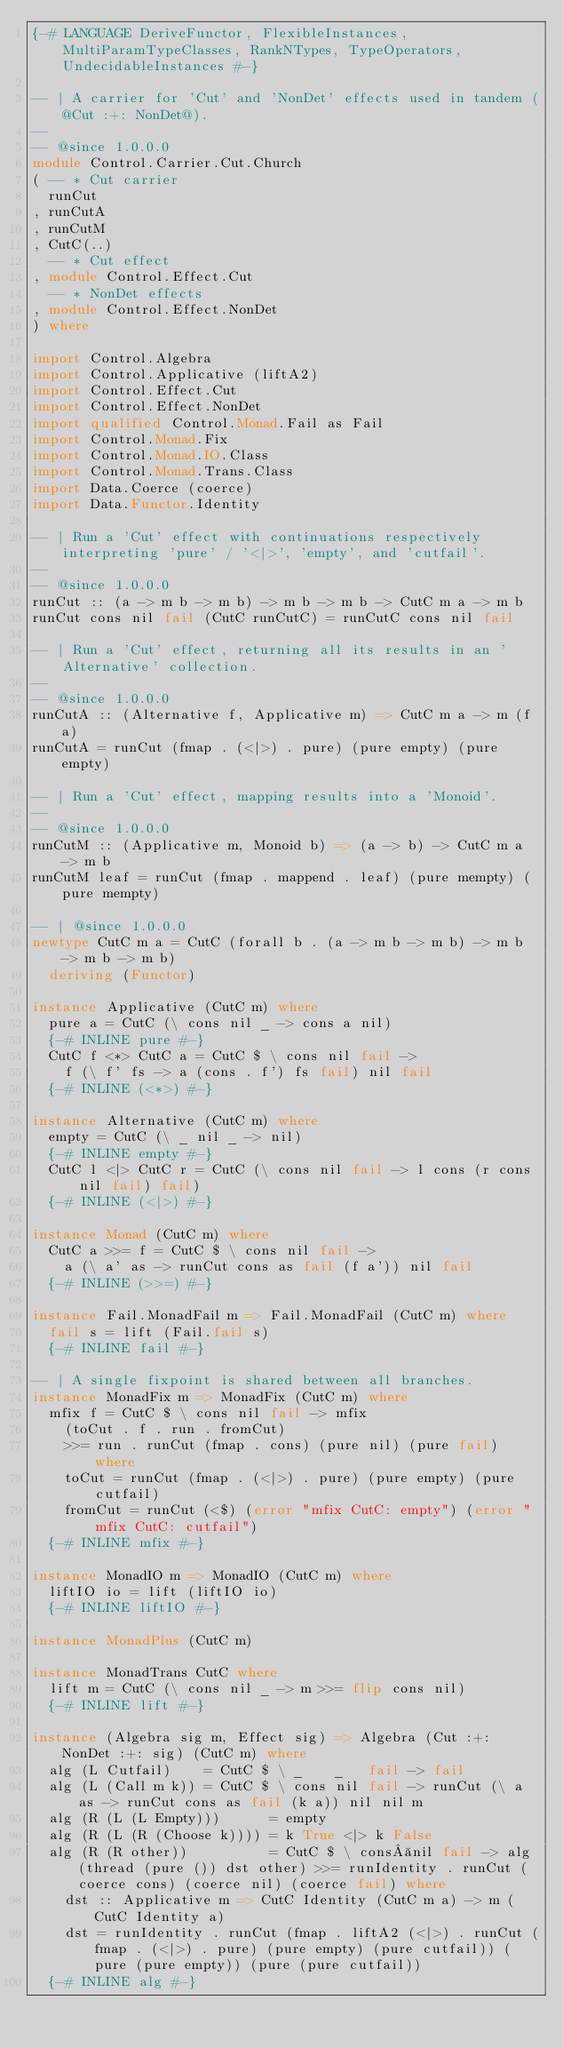Convert code to text. <code><loc_0><loc_0><loc_500><loc_500><_Haskell_>{-# LANGUAGE DeriveFunctor, FlexibleInstances, MultiParamTypeClasses, RankNTypes, TypeOperators, UndecidableInstances #-}

-- | A carrier for 'Cut' and 'NonDet' effects used in tandem (@Cut :+: NonDet@).
--
-- @since 1.0.0.0
module Control.Carrier.Cut.Church
( -- * Cut carrier
  runCut
, runCutA
, runCutM
, CutC(..)
  -- * Cut effect
, module Control.Effect.Cut
  -- * NonDet effects
, module Control.Effect.NonDet
) where

import Control.Algebra
import Control.Applicative (liftA2)
import Control.Effect.Cut
import Control.Effect.NonDet
import qualified Control.Monad.Fail as Fail
import Control.Monad.Fix
import Control.Monad.IO.Class
import Control.Monad.Trans.Class
import Data.Coerce (coerce)
import Data.Functor.Identity

-- | Run a 'Cut' effect with continuations respectively interpreting 'pure' / '<|>', 'empty', and 'cutfail'.
--
-- @since 1.0.0.0
runCut :: (a -> m b -> m b) -> m b -> m b -> CutC m a -> m b
runCut cons nil fail (CutC runCutC) = runCutC cons nil fail

-- | Run a 'Cut' effect, returning all its results in an 'Alternative' collection.
--
-- @since 1.0.0.0
runCutA :: (Alternative f, Applicative m) => CutC m a -> m (f a)
runCutA = runCut (fmap . (<|>) . pure) (pure empty) (pure empty)

-- | Run a 'Cut' effect, mapping results into a 'Monoid'.
--
-- @since 1.0.0.0
runCutM :: (Applicative m, Monoid b) => (a -> b) -> CutC m a -> m b
runCutM leaf = runCut (fmap . mappend . leaf) (pure mempty) (pure mempty)

-- | @since 1.0.0.0
newtype CutC m a = CutC (forall b . (a -> m b -> m b) -> m b -> m b -> m b)
  deriving (Functor)

instance Applicative (CutC m) where
  pure a = CutC (\ cons nil _ -> cons a nil)
  {-# INLINE pure #-}
  CutC f <*> CutC a = CutC $ \ cons nil fail ->
    f (\ f' fs -> a (cons . f') fs fail) nil fail
  {-# INLINE (<*>) #-}

instance Alternative (CutC m) where
  empty = CutC (\ _ nil _ -> nil)
  {-# INLINE empty #-}
  CutC l <|> CutC r = CutC (\ cons nil fail -> l cons (r cons nil fail) fail)
  {-# INLINE (<|>) #-}

instance Monad (CutC m) where
  CutC a >>= f = CutC $ \ cons nil fail ->
    a (\ a' as -> runCut cons as fail (f a')) nil fail
  {-# INLINE (>>=) #-}

instance Fail.MonadFail m => Fail.MonadFail (CutC m) where
  fail s = lift (Fail.fail s)
  {-# INLINE fail #-}

-- | A single fixpoint is shared between all branches.
instance MonadFix m => MonadFix (CutC m) where
  mfix f = CutC $ \ cons nil fail -> mfix
    (toCut . f . run . fromCut)
    >>= run . runCut (fmap . cons) (pure nil) (pure fail) where
    toCut = runCut (fmap . (<|>) . pure) (pure empty) (pure cutfail)
    fromCut = runCut (<$) (error "mfix CutC: empty") (error "mfix CutC: cutfail")
  {-# INLINE mfix #-}

instance MonadIO m => MonadIO (CutC m) where
  liftIO io = lift (liftIO io)
  {-# INLINE liftIO #-}

instance MonadPlus (CutC m)

instance MonadTrans CutC where
  lift m = CutC (\ cons nil _ -> m >>= flip cons nil)
  {-# INLINE lift #-}

instance (Algebra sig m, Effect sig) => Algebra (Cut :+: NonDet :+: sig) (CutC m) where
  alg (L Cutfail)    = CutC $ \ _    _   fail -> fail
  alg (L (Call m k)) = CutC $ \ cons nil fail -> runCut (\ a as -> runCut cons as fail (k a)) nil nil m
  alg (R (L (L Empty)))      = empty
  alg (R (L (R (Choose k)))) = k True <|> k False
  alg (R (R other))          = CutC $ \ cons nil fail -> alg (thread (pure ()) dst other) >>= runIdentity . runCut (coerce cons) (coerce nil) (coerce fail) where
    dst :: Applicative m => CutC Identity (CutC m a) -> m (CutC Identity a)
    dst = runIdentity . runCut (fmap . liftA2 (<|>) . runCut (fmap . (<|>) . pure) (pure empty) (pure cutfail)) (pure (pure empty)) (pure (pure cutfail))
  {-# INLINE alg #-}
</code> 